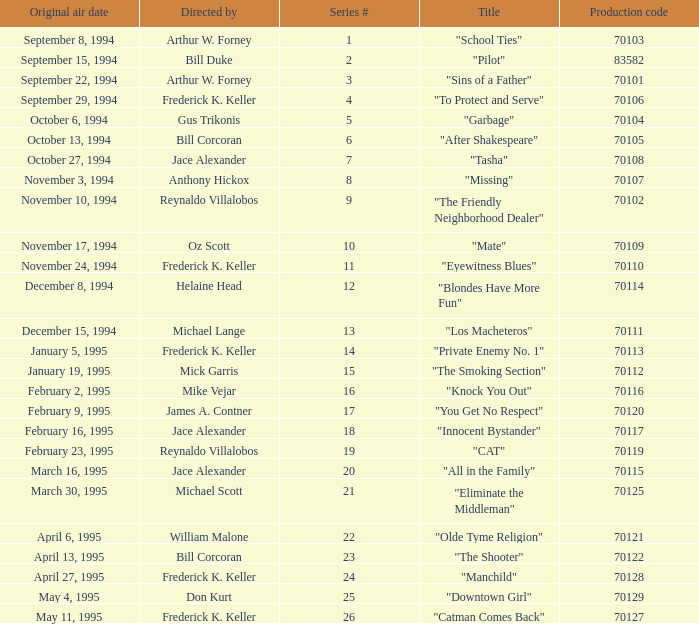What was the lowest production code value in series #10? 70109.0. Parse the full table. {'header': ['Original air date', 'Directed by', 'Series #', 'Title', 'Production code'], 'rows': [['September 8, 1994', 'Arthur W. Forney', '1', '"School Ties"', '70103'], ['September 15, 1994', 'Bill Duke', '2', '"Pilot"', '83582'], ['September 22, 1994', 'Arthur W. Forney', '3', '"Sins of a Father"', '70101'], ['September 29, 1994', 'Frederick K. Keller', '4', '"To Protect and Serve"', '70106'], ['October 6, 1994', 'Gus Trikonis', '5', '"Garbage"', '70104'], ['October 13, 1994', 'Bill Corcoran', '6', '"After Shakespeare"', '70105'], ['October 27, 1994', 'Jace Alexander', '7', '"Tasha"', '70108'], ['November 3, 1994', 'Anthony Hickox', '8', '"Missing"', '70107'], ['November 10, 1994', 'Reynaldo Villalobos', '9', '"The Friendly Neighborhood Dealer"', '70102'], ['November 17, 1994', 'Oz Scott', '10', '"Mate"', '70109'], ['November 24, 1994', 'Frederick K. Keller', '11', '"Eyewitness Blues"', '70110'], ['December 8, 1994', 'Helaine Head', '12', '"Blondes Have More Fun"', '70114'], ['December 15, 1994', 'Michael Lange', '13', '"Los Macheteros"', '70111'], ['January 5, 1995', 'Frederick K. Keller', '14', '"Private Enemy No. 1"', '70113'], ['January 19, 1995', 'Mick Garris', '15', '"The Smoking Section"', '70112'], ['February 2, 1995', 'Mike Vejar', '16', '"Knock You Out"', '70116'], ['February 9, 1995', 'James A. Contner', '17', '"You Get No Respect"', '70120'], ['February 16, 1995', 'Jace Alexander', '18', '"Innocent Bystander"', '70117'], ['February 23, 1995', 'Reynaldo Villalobos', '19', '"CAT"', '70119'], ['March 16, 1995', 'Jace Alexander', '20', '"All in the Family"', '70115'], ['March 30, 1995', 'Michael Scott', '21', '"Eliminate the Middleman"', '70125'], ['April 6, 1995', 'William Malone', '22', '"Olde Tyme Religion"', '70121'], ['April 13, 1995', 'Bill Corcoran', '23', '"The Shooter"', '70122'], ['April 27, 1995', 'Frederick K. Keller', '24', '"Manchild"', '70128'], ['May 4, 1995', 'Don Kurt', '25', '"Downtown Girl"', '70129'], ['May 11, 1995', 'Frederick K. Keller', '26', '"Catman Comes Back"', '70127']]} 